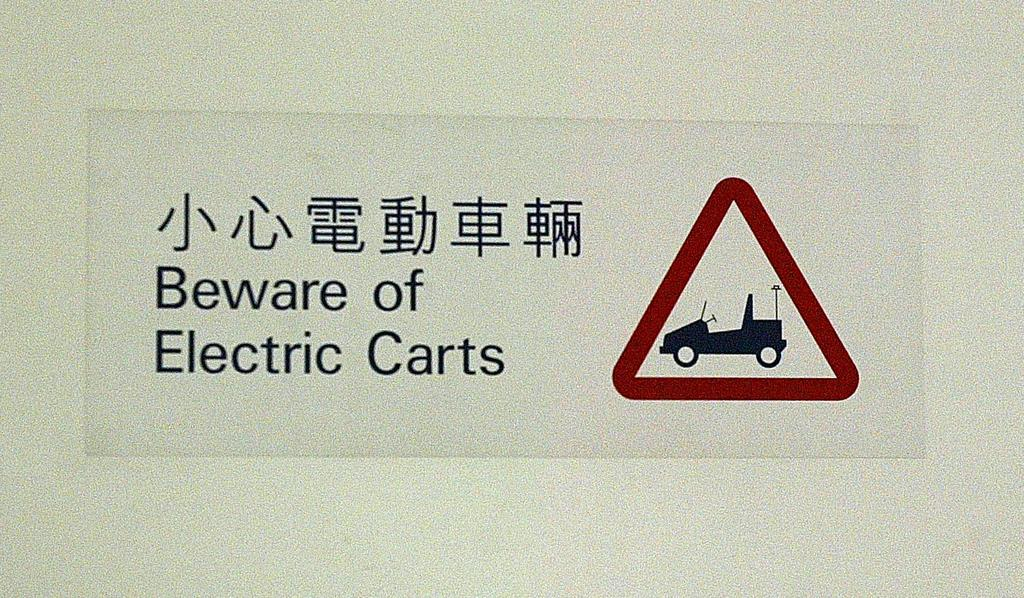What is featured on the poster in the image? The poster contains a sign and a vehicle. What else can be found on the poster? There is text written on the poster. How many lizards are crawling on the poster in the image? There are no lizards present on the poster in the image. What type of cracker is being advertised on the poster? The poster does not contain any information about crackers, as it features a sign, a vehicle, and text related to something else. 